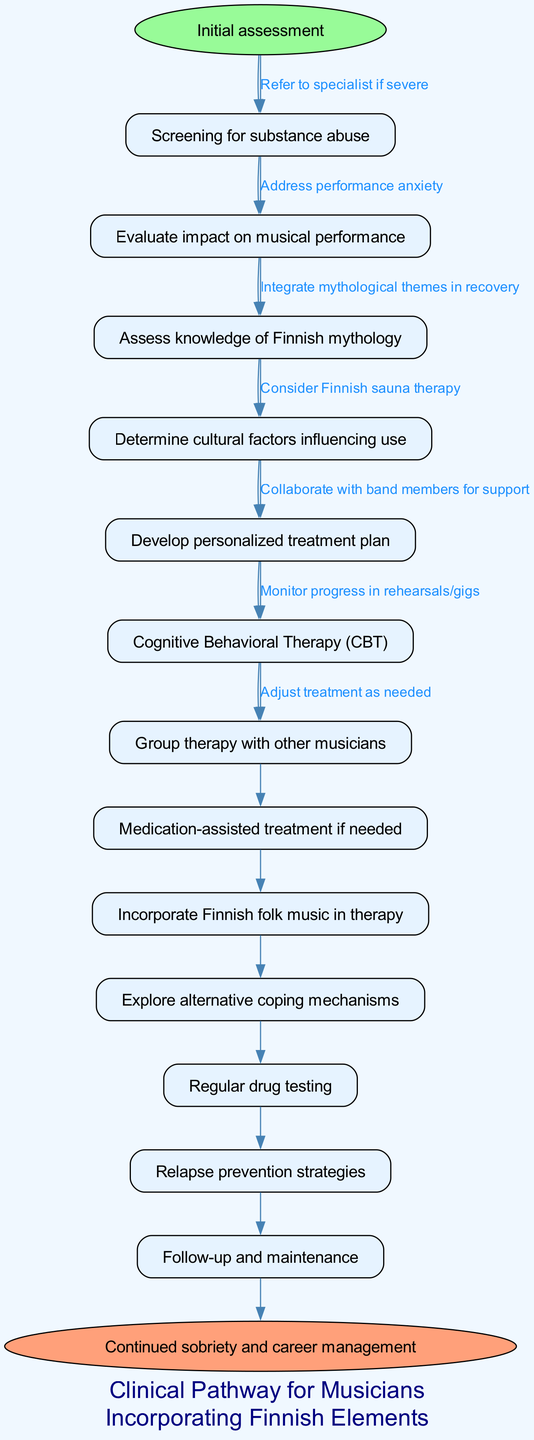What is the first step in the clinical pathway? The diagram indicates that the first step is 'Initial assessment', which is the starting point of the pathway.
Answer: Initial assessment How many nodes are present in the diagram? Counting the nodes listed in the data, there are 12 nodes excluding the start and end, leading to a total of 14 nodes in the diagram.
Answer: 14 What type of therapy is included in the pathway? The diagram specifies 'Cognitive Behavioral Therapy (CBT)' as one of the therapeutic approaches included in the pathway.
Answer: Cognitive Behavioral Therapy (CBT) Which element is added to therapy sessions to incorporate Finnish culture? The pathway includes 'Incorporate Finnish folk music in therapy' as a method to integrate cultural elements into treatment.
Answer: Incorporate Finnish folk music in therapy What is the final goal indicated in the pathway? The endpoint of the diagram is stated as 'Continued sobriety and career management', representing the ultimate objective of the clinical management process.
Answer: Continued sobriety and career management In what situation should a referral to a specialist be made? According to the diagram, a referral to a specialist should be made if the substance abuse issue is categorized as severe, which is indicated by a direct edge from the initial assessments.
Answer: Refer to specialist if severe How do group therapy sessions involve other musicians? The diagram mentions 'Group therapy with other musicians', showing the collaborative approach that leverages shared experiences in the music industry.
Answer: Group therapy with other musicians What cultural factor is to be assessed regarding substance use? The pathway includes 'Determine cultural factors influencing use', indicating the importance of understanding the cultural context in the management of substance abuse.
Answer: Determine cultural factors influencing use How are relapse prevention strategies integrated according to the pathway? The pathway states 'Relapse prevention strategies' as a part of treatment, suggesting active measures to avoid relapse are to be planned and monitored throughout the recovery process.
Answer: Relapse prevention strategies 